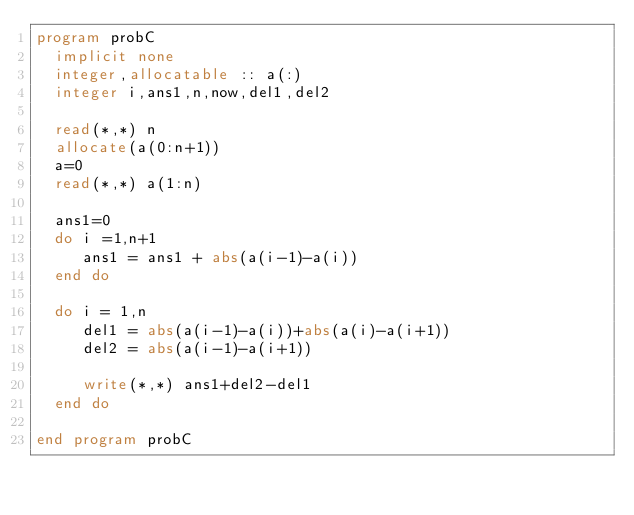<code> <loc_0><loc_0><loc_500><loc_500><_FORTRAN_>program probC
  implicit none
  integer,allocatable :: a(:)
  integer i,ans1,n,now,del1,del2

  read(*,*) n
  allocate(a(0:n+1))
  a=0
  read(*,*) a(1:n)

  ans1=0
  do i =1,n+1
     ans1 = ans1 + abs(a(i-1)-a(i))
  end do

  do i = 1,n
     del1 = abs(a(i-1)-a(i))+abs(a(i)-a(i+1))
     del2 = abs(a(i-1)-a(i+1))

     write(*,*) ans1+del2-del1
  end do
  
end program probC
</code> 